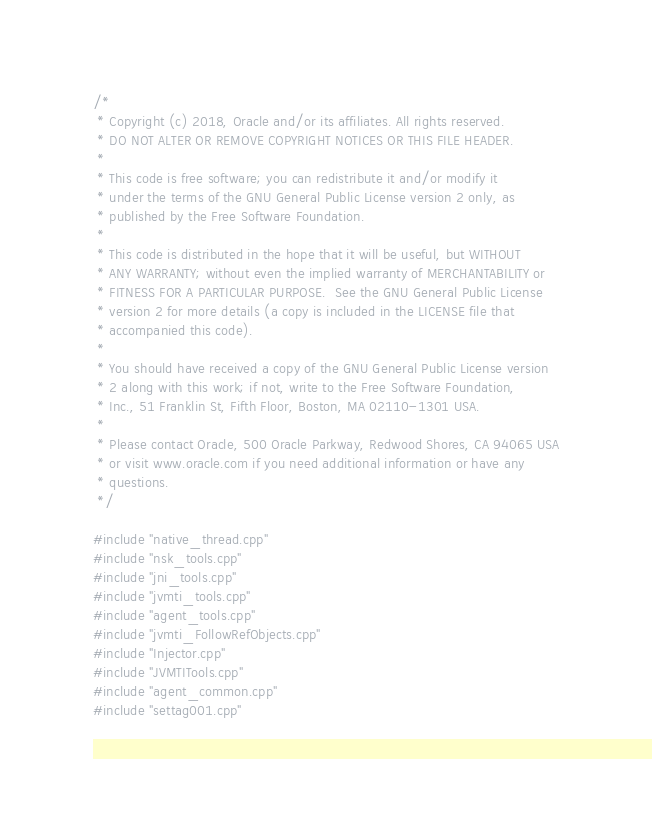<code> <loc_0><loc_0><loc_500><loc_500><_C++_>/*
 * Copyright (c) 2018, Oracle and/or its affiliates. All rights reserved.
 * DO NOT ALTER OR REMOVE COPYRIGHT NOTICES OR THIS FILE HEADER.
 *
 * This code is free software; you can redistribute it and/or modify it
 * under the terms of the GNU General Public License version 2 only, as
 * published by the Free Software Foundation.
 *
 * This code is distributed in the hope that it will be useful, but WITHOUT
 * ANY WARRANTY; without even the implied warranty of MERCHANTABILITY or
 * FITNESS FOR A PARTICULAR PURPOSE.  See the GNU General Public License
 * version 2 for more details (a copy is included in the LICENSE file that
 * accompanied this code).
 *
 * You should have received a copy of the GNU General Public License version
 * 2 along with this work; if not, write to the Free Software Foundation,
 * Inc., 51 Franklin St, Fifth Floor, Boston, MA 02110-1301 USA.
 *
 * Please contact Oracle, 500 Oracle Parkway, Redwood Shores, CA 94065 USA
 * or visit www.oracle.com if you need additional information or have any
 * questions.
 */

#include "native_thread.cpp"
#include "nsk_tools.cpp"
#include "jni_tools.cpp"
#include "jvmti_tools.cpp"
#include "agent_tools.cpp"
#include "jvmti_FollowRefObjects.cpp"
#include "Injector.cpp"
#include "JVMTITools.cpp"
#include "agent_common.cpp"
#include "settag001.cpp"
</code> 